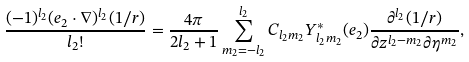Convert formula to latex. <formula><loc_0><loc_0><loc_500><loc_500>\frac { ( - 1 ) ^ { l _ { 2 } } ( { e } _ { 2 } \cdot \nabla ) ^ { l _ { 2 } } ( 1 / r ) } { l _ { 2 } ! } = \frac { 4 \pi } { 2 l _ { 2 } + 1 } \sum _ { m _ { 2 } = - l _ { 2 } } ^ { l _ { 2 } } C _ { l _ { 2 } m _ { 2 } } Y ^ { * } _ { l _ { 2 } m _ { 2 } } ( { e _ { 2 } } ) \frac { \partial ^ { l _ { 2 } } ( 1 / r ) } { \partial z ^ { l _ { 2 } - m _ { 2 } } \partial \eta ^ { m _ { 2 } } } ,</formula> 